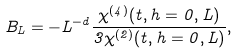<formula> <loc_0><loc_0><loc_500><loc_500>B _ { L } = - L ^ { - d } \frac { \chi ^ { ( 4 ) } ( t , h = 0 , L ) } { 3 \chi ^ { ( 2 ) } ( t , h = 0 , L ) } ,</formula> 